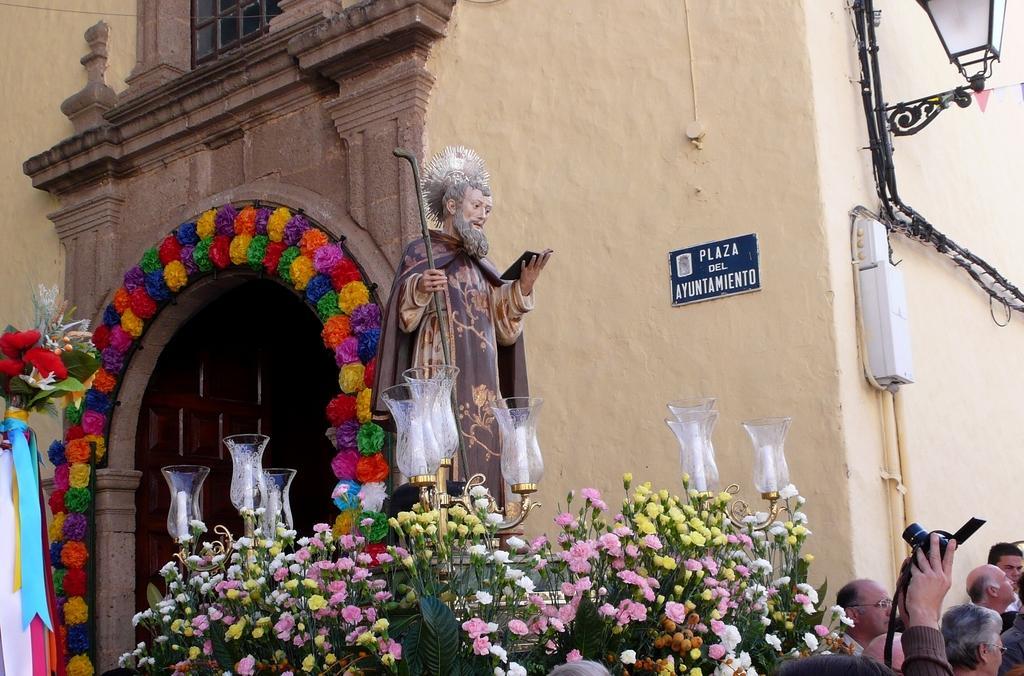In one or two sentences, can you explain what this image depicts? In this picture, we can see statue, some flowers, candles in glass objects with poles, and we can see the wall with an arch, window, and we can see some object attached to it like, light, poles, and we can see flowers on the left side of the picture, we can see a few people, and a person holding a camera. 